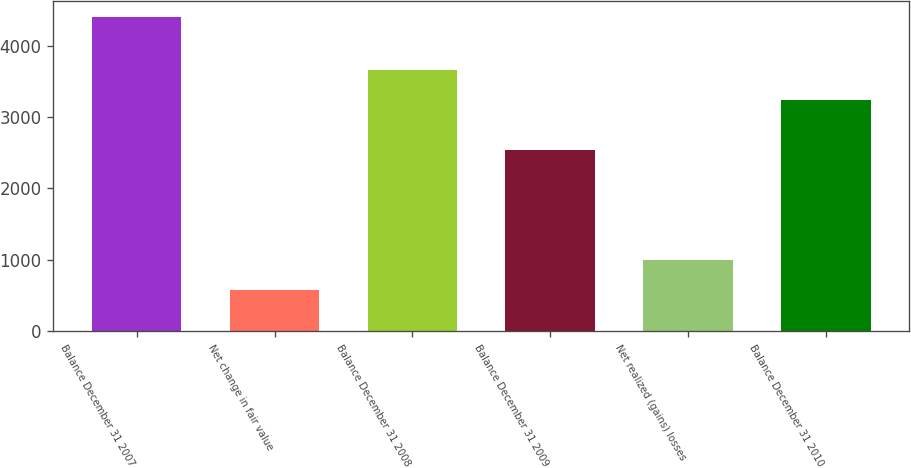Convert chart. <chart><loc_0><loc_0><loc_500><loc_500><bar_chart><fcel>Balance December 31 2007<fcel>Net change in fair value<fcel>Balance December 31 2008<fcel>Balance December 31 2009<fcel>Net realized (gains) losses<fcel>Balance December 31 2010<nl><fcel>4402<fcel>572.5<fcel>3661.5<fcel>2535<fcel>998<fcel>3236<nl></chart> 